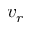<formula> <loc_0><loc_0><loc_500><loc_500>v _ { r }</formula> 